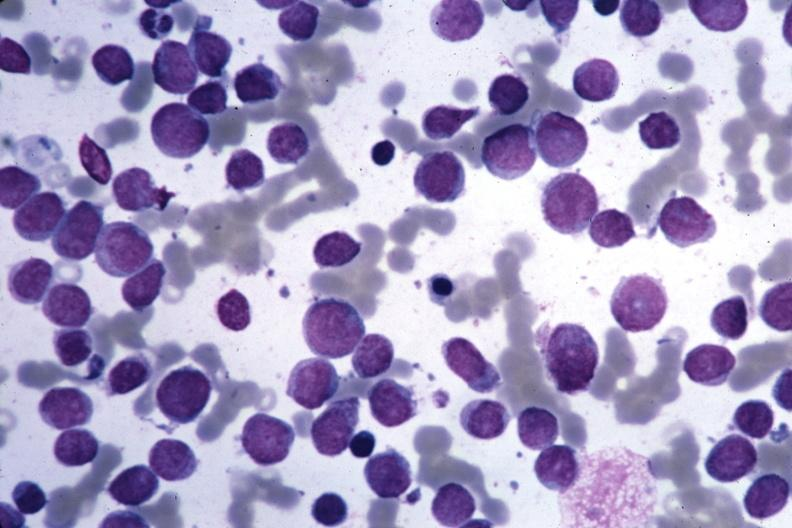what is present?
Answer the question using a single word or phrase. Bone marrow 